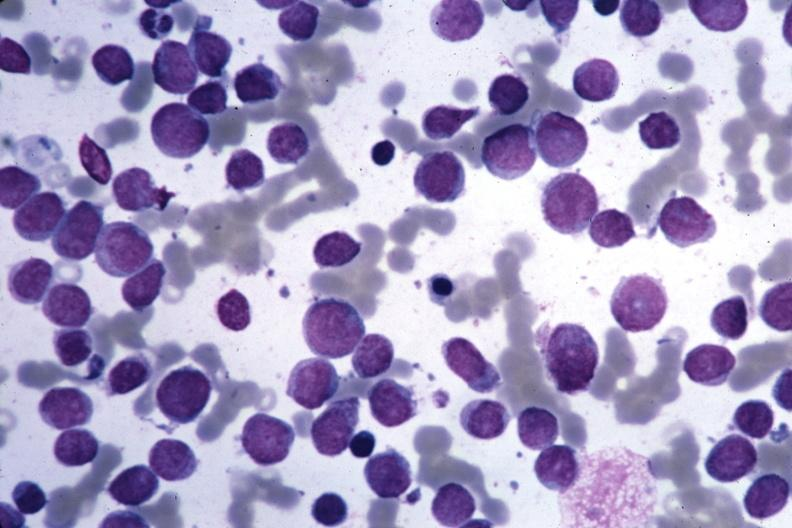what is present?
Answer the question using a single word or phrase. Bone marrow 